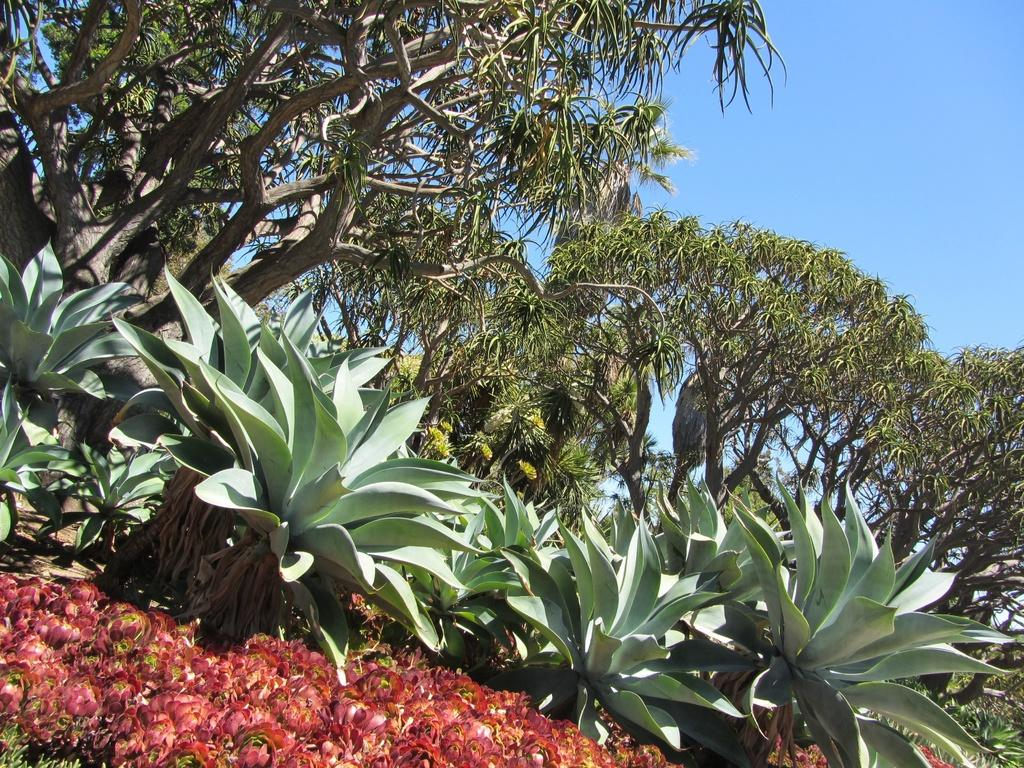What type of vegetation can be seen in the image? There are plants and trees in the image. What part of the natural environment is visible in the image? The sky is visible in the image. What type of loaf can be seen in the image? There is no loaf present in the image; it features plants, trees, and the sky. 